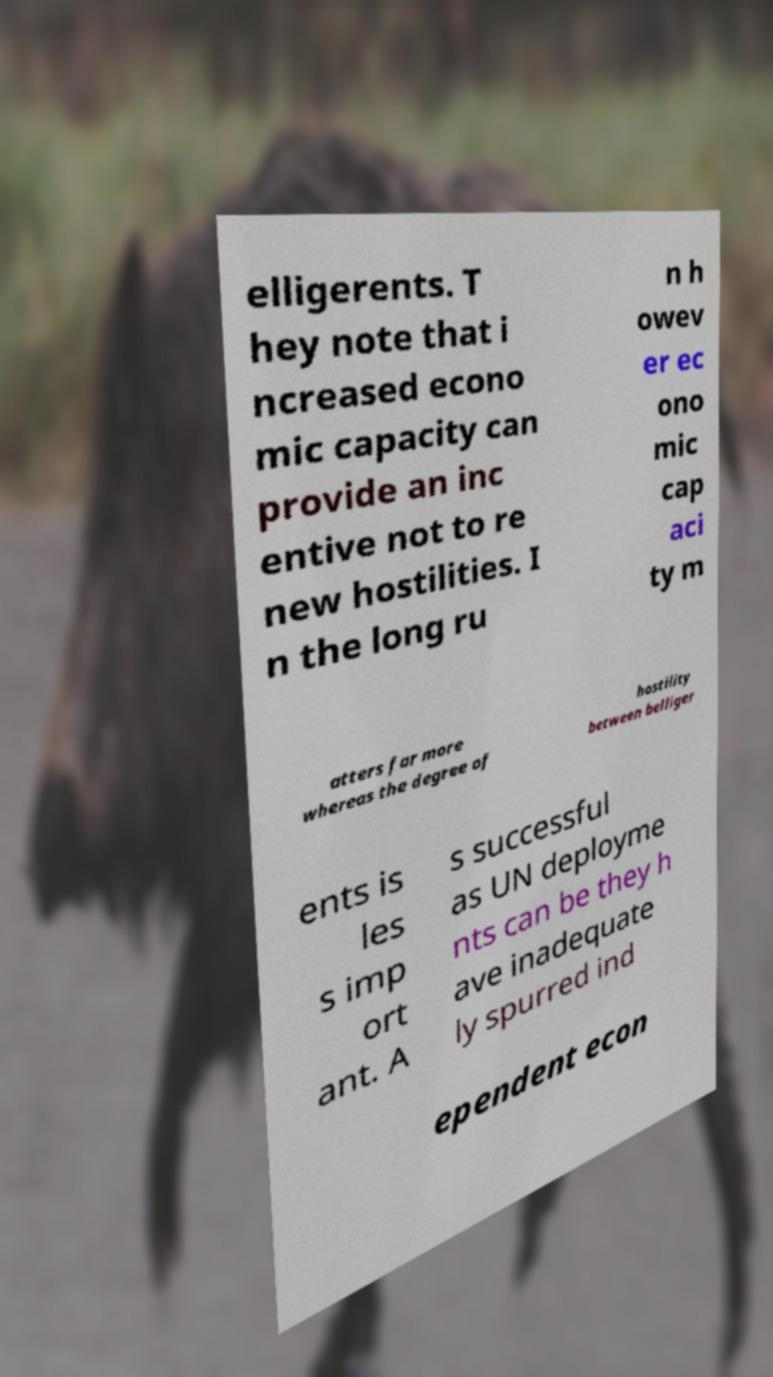I need the written content from this picture converted into text. Can you do that? elligerents. T hey note that i ncreased econo mic capacity can provide an inc entive not to re new hostilities. I n the long ru n h owev er ec ono mic cap aci ty m atters far more whereas the degree of hostility between belliger ents is les s imp ort ant. A s successful as UN deployme nts can be they h ave inadequate ly spurred ind ependent econ 